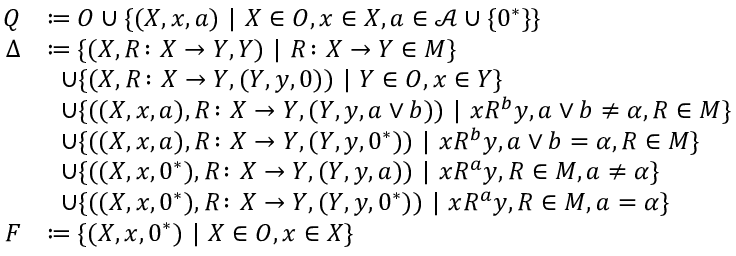Convert formula to latex. <formula><loc_0><loc_0><loc_500><loc_500>\begin{array} { r l } { Q } & { \colon e q O \cup \{ ( X , x , a ) | X \in O , x \in X , a \in \mathcal { A } \cup \{ 0 ^ { * } \} \} } \\ { \Delta } & { \colon e q \{ ( X , R \colon X \to Y , Y ) | R \colon X \to Y \in M \} } \\ & { \, \cup \{ ( X , R \colon X \to Y , ( Y , y , 0 ) ) | Y \in O , x \in Y \} } \\ & { \, \cup \{ ( ( X , x , a ) , R \colon X \to Y , ( Y , y , a \vee b ) ) | x R ^ { b } y , a \vee b \neq \alpha , R \in M \} } \\ & { \, \cup \{ ( ( X , x , a ) , R \colon X \to Y , ( Y , y , 0 ^ { * } ) ) | x R ^ { b } y , a \vee b = \alpha , R \in M \} } \\ & { \, \cup \{ ( ( X , x , 0 ^ { * } ) , R \colon X \to Y , ( Y , y , a ) ) | x R ^ { a } y , R \in M , a \neq \alpha \} } \\ & { \, \cup \{ ( ( X , x , 0 ^ { * } ) , R \colon X \to Y , ( Y , y , 0 ^ { * } ) ) | x R ^ { a } y , R \in M , a = \alpha \} } \\ { F } & { \colon e q \{ ( X , x , 0 ^ { * } ) | X \in O , x \in X \} } \end{array}</formula> 